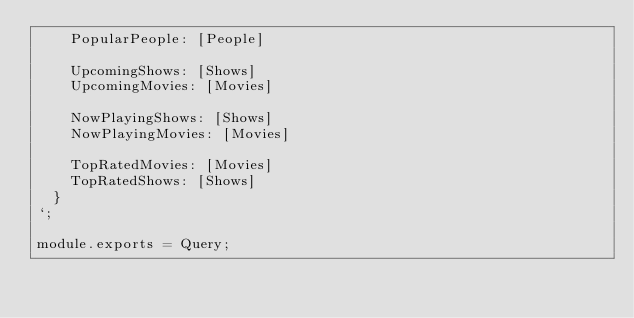<code> <loc_0><loc_0><loc_500><loc_500><_JavaScript_>		PopularPeople: [People]

		UpcomingShows: [Shows]
		UpcomingMovies: [Movies]

		NowPlayingShows: [Shows]
		NowPlayingMovies: [Movies]

		TopRatedMovies: [Movies]
		TopRatedShows: [Shows]
	}
`;

module.exports = Query;
</code> 